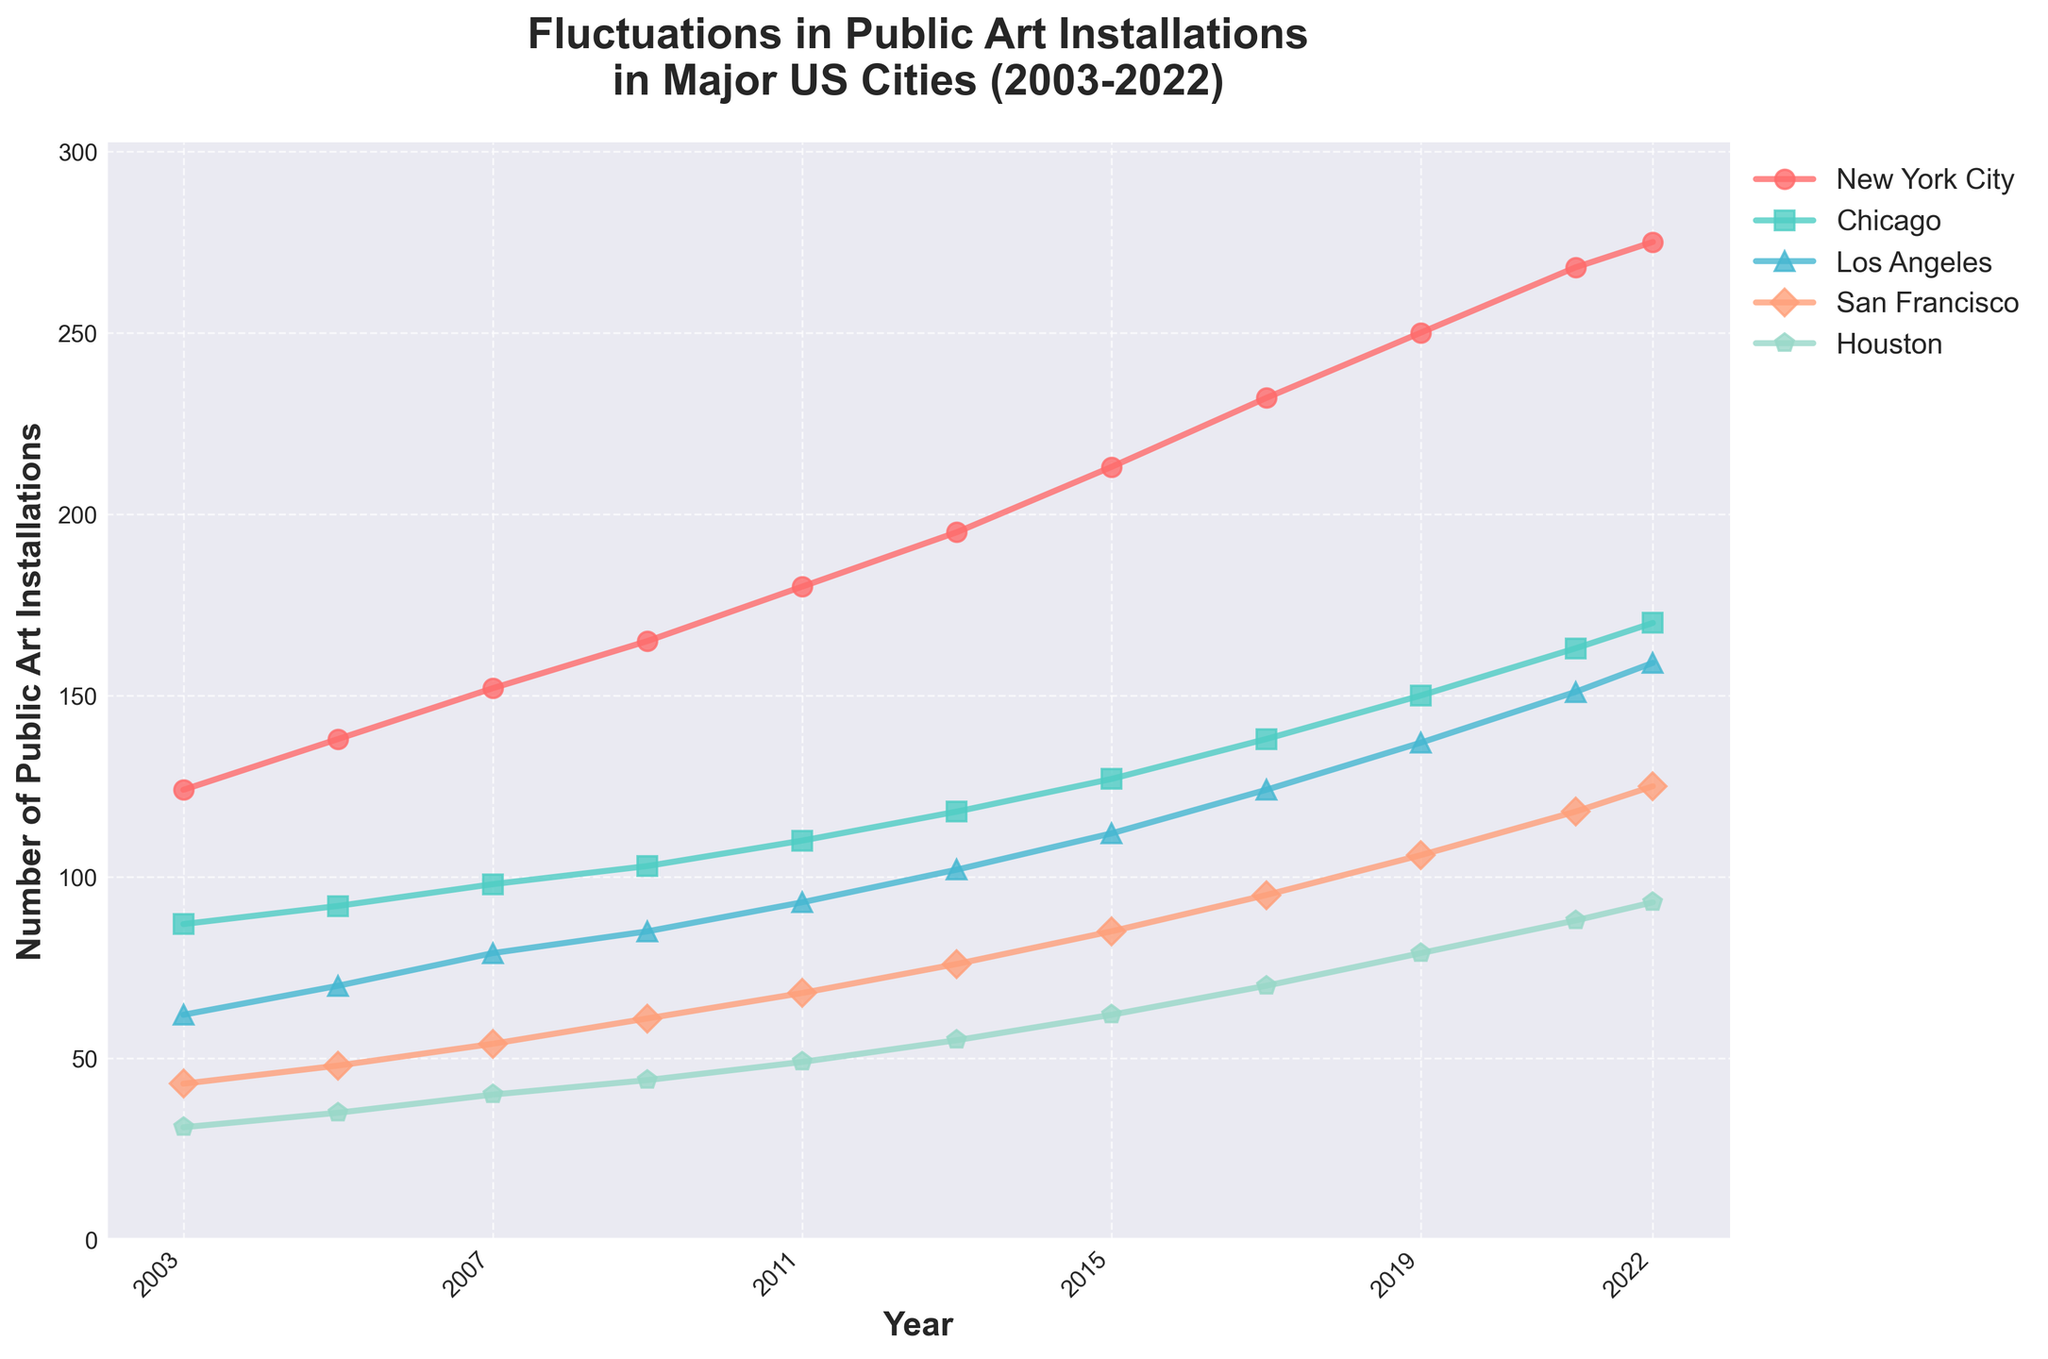When did San Francisco surpass 50 public art installations for the first time? Look at the line for San Francisco. The value first exceeds 50 between 2007 and 2009. In 2009, the number is 61, so the first year it surpasses 50 is 2009.
Answer: 2009 Which city had the highest number of public art installations in 2022? Look at the endpoints in 2022 for each city. New York City has the highest value at 275.
Answer: New York City How many more public art installations did New York City have compared to Chicago in 2019? Look at the values for New York City and Chicago in 2019. New York City had 250 while Chicago had 150. The difference is 250 - 150.
Answer: 100 What is the trend of public art installations in Houston from 2003 to 2022? Look at the line for Houston from the starting point to the endpoint. The trend is consistently increasing over the given years.
Answer: Increasing Which year had the largest increase in public art installations for Los Angeles? Compare the year-over-year differences for Los Angeles. The largest increase is from 2013 to 2015, increasing from 102 to 112, which is an increase of 10.
Answer: 2013-2015 On average, how many public art installations were there in San Francisco every year from 2003 to 2022? Sum the values for San Francisco from 2003 to 2022: 43+48+54+61+68+76+85+95+106+118+125 = 879. Divide this sum by the number of years (11): 879/11.
Answer: 80 Which two cities had the closest number of public art installations in 2015? Compare the values for each city in 2015: New York City (213), Chicago (127), Los Angeles (112), San Francisco (85), and Houston (62). The closest values are Los Angeles and San Francisco (112 and 85, respectively).
Answer: Los Angeles and San Francisco Was there any year where the number of public art installations decreased for any city? If so, for which city and year? Check the year-over-year values for each city. No decrease is observed; all values either remain stable or increase over the years.
Answer: No What is the highest number of public art installations reached by any city by 2022? Check the values for each city in 2022. The highest value is for New York City, which is 275.
Answer: 275 How did the number of public art installations in Chicago change from 2005 to 2017? Chicago's number of installations in 2005 was 92 and in 2017 it was 138. To find the change, subtract 92 from 138.
Answer: Increased by 46 